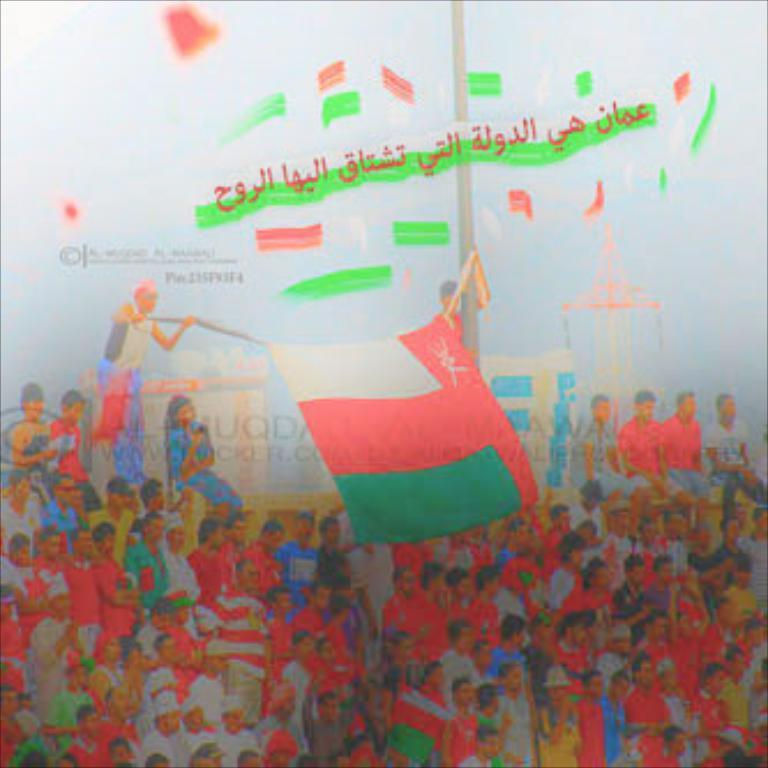What can be seen in the image involving people? There are people standing in the image. What is located at the center of the image? There is text at the center of the image. What is another object present in the image? There is a flag in the image. Where is additional text located in the image? There is text at the top of the image. What type of cabbage is being used to express shame in the image? There is no cabbage or expression of shame present in the image. Can you tell me how many basketballs are visible in the image? There are no basketballs present in the image. 